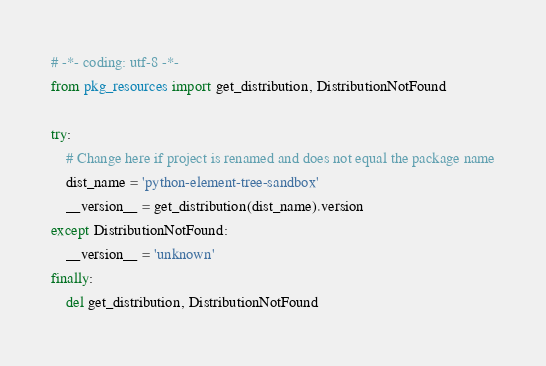<code> <loc_0><loc_0><loc_500><loc_500><_Python_># -*- coding: utf-8 -*-
from pkg_resources import get_distribution, DistributionNotFound

try:
    # Change here if project is renamed and does not equal the package name
    dist_name = 'python-element-tree-sandbox'
    __version__ = get_distribution(dist_name).version
except DistributionNotFound:
    __version__ = 'unknown'
finally:
    del get_distribution, DistributionNotFound
</code> 